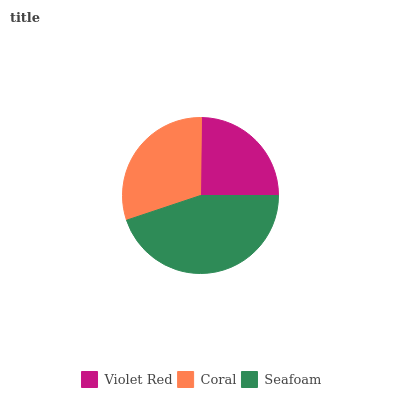Is Violet Red the minimum?
Answer yes or no. Yes. Is Seafoam the maximum?
Answer yes or no. Yes. Is Coral the minimum?
Answer yes or no. No. Is Coral the maximum?
Answer yes or no. No. Is Coral greater than Violet Red?
Answer yes or no. Yes. Is Violet Red less than Coral?
Answer yes or no. Yes. Is Violet Red greater than Coral?
Answer yes or no. No. Is Coral less than Violet Red?
Answer yes or no. No. Is Coral the high median?
Answer yes or no. Yes. Is Coral the low median?
Answer yes or no. Yes. Is Seafoam the high median?
Answer yes or no. No. Is Violet Red the low median?
Answer yes or no. No. 